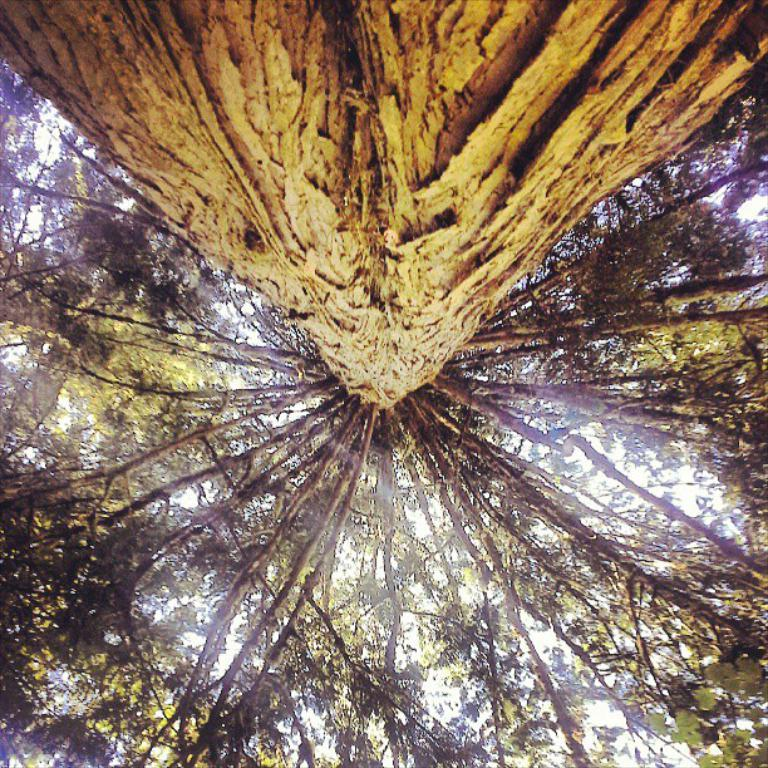What is the primary feature of the image? The primary feature of the image is the presence of many trees. Can you describe any specific part of a tree that is visible in the image? Yes, a tree stem is visible in the image. How does the wool affect the trees in the image? There is no wool present in the image, so it cannot affect the trees. 